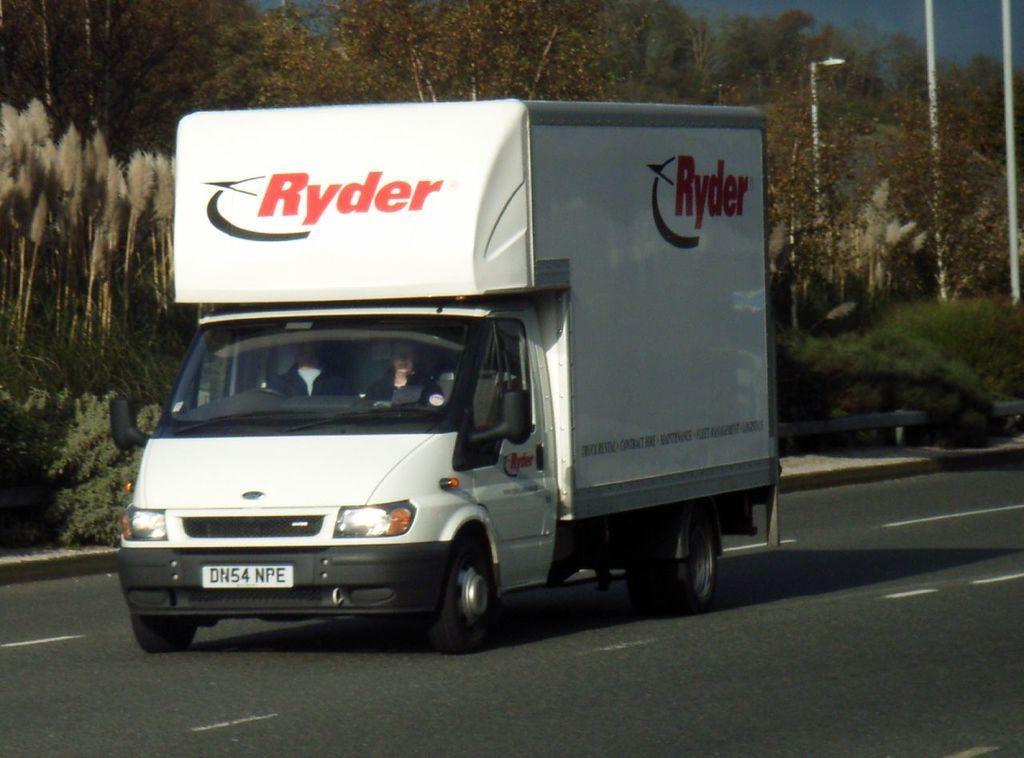How would you summarize this image in a sentence or two? In this picture I can see a white color truck on the road. In the truck I can see some people are sitting. In the background I can see trees, street lights and white color poles. Here I can see some white color lines on the road. On the track I can see a logo. 